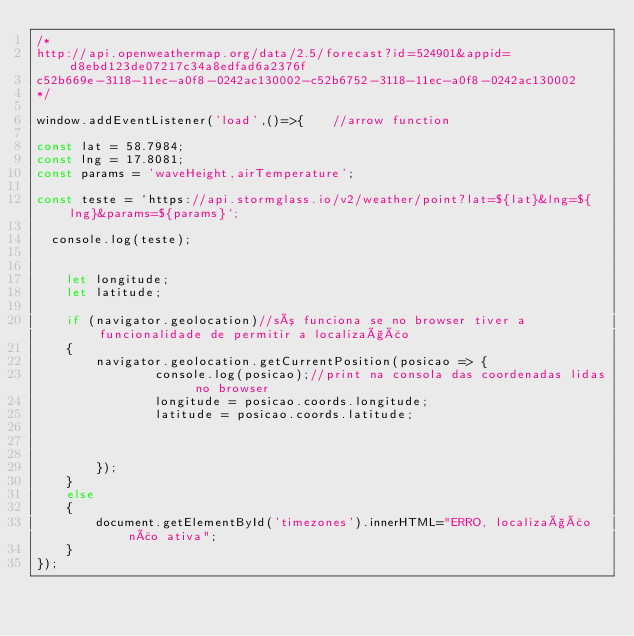<code> <loc_0><loc_0><loc_500><loc_500><_JavaScript_>/*
http://api.openweathermap.org/data/2.5/forecast?id=524901&appid=d8ebd123de07217c34a8edfad6a2376f
c52b669e-3118-11ec-a0f8-0242ac130002-c52b6752-3118-11ec-a0f8-0242ac130002
*/

window.addEventListener('load',()=>{    //arrow function

const lat = 58.7984;
const lng = 17.8081;
const params = 'waveHeight,airTemperature';

const teste = `https://api.stormglass.io/v2/weather/point?lat=${lat}&lng=${lng}&params=${params}`;

  console.log(teste);


    let longitude;
    let latitude;

    if (navigator.geolocation)//só funciona se no browser tiver a funcionalidade de permitir a localização
    {
        navigator.geolocation.getCurrentPosition(posicao => {
                console.log(posicao);//print na consola das coordenadas lidas no browser
                longitude = posicao.coords.longitude;
                latitude = posicao.coords.latitude;


             
        });
    }
    else
    {
        document.getElementById('timezones').innerHTML="ERRO, localização não ativa";
    }
});</code> 